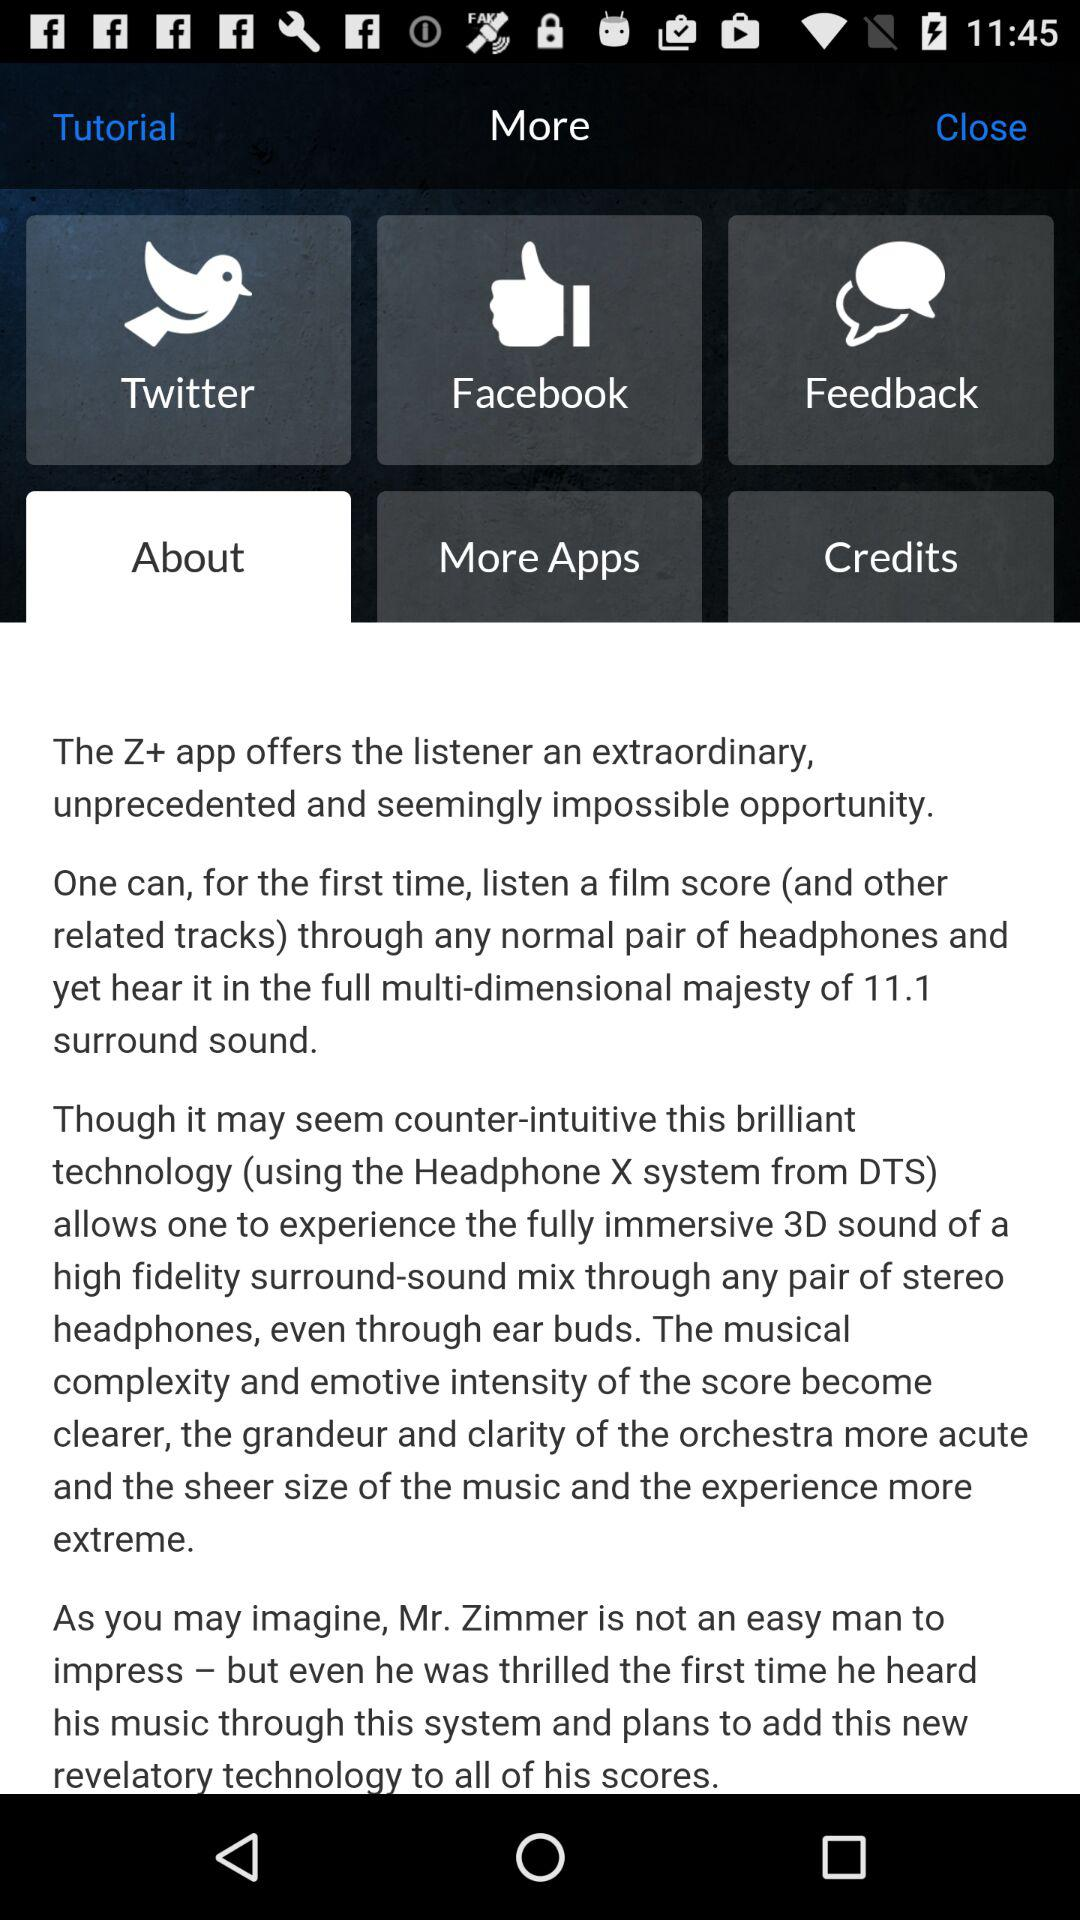What is the name of the application? The names of the applications are "Twitter", "Facebook" and "Z+". 